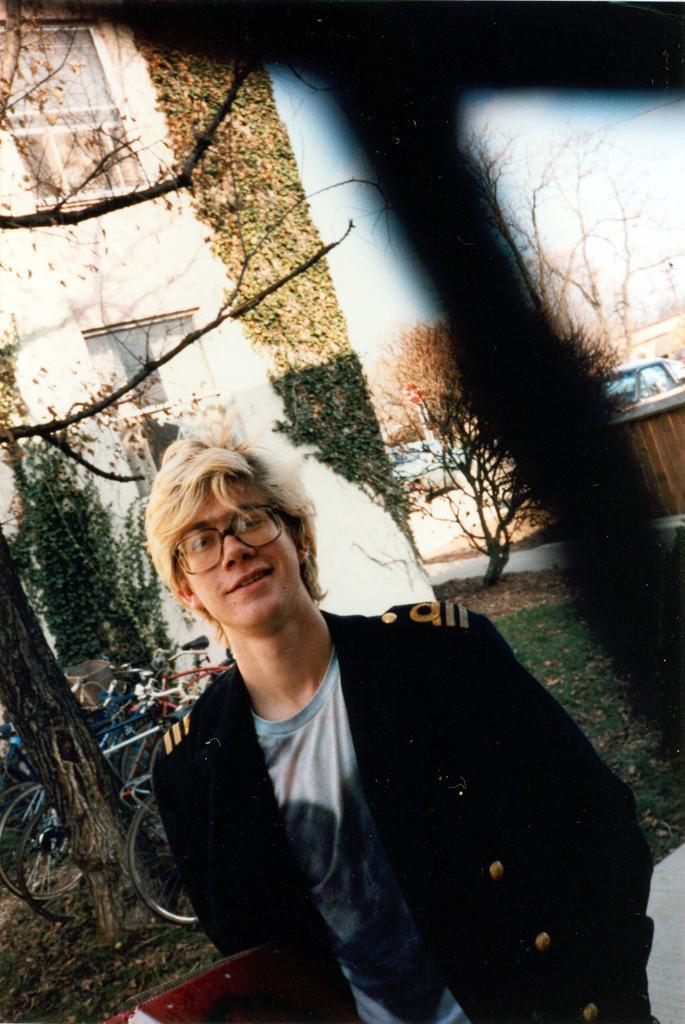Could you give a brief overview of what you see in this image? The man in the front of the picture wearing the black jacket is standing and he is smiling. He is even wearing the spectacles. Behind him, we see many bicycles. On the left side, we see a white building which is covered with creeper plants. On the right side, we see cars parked on the road. There are trees in the background. We even see the sky. 